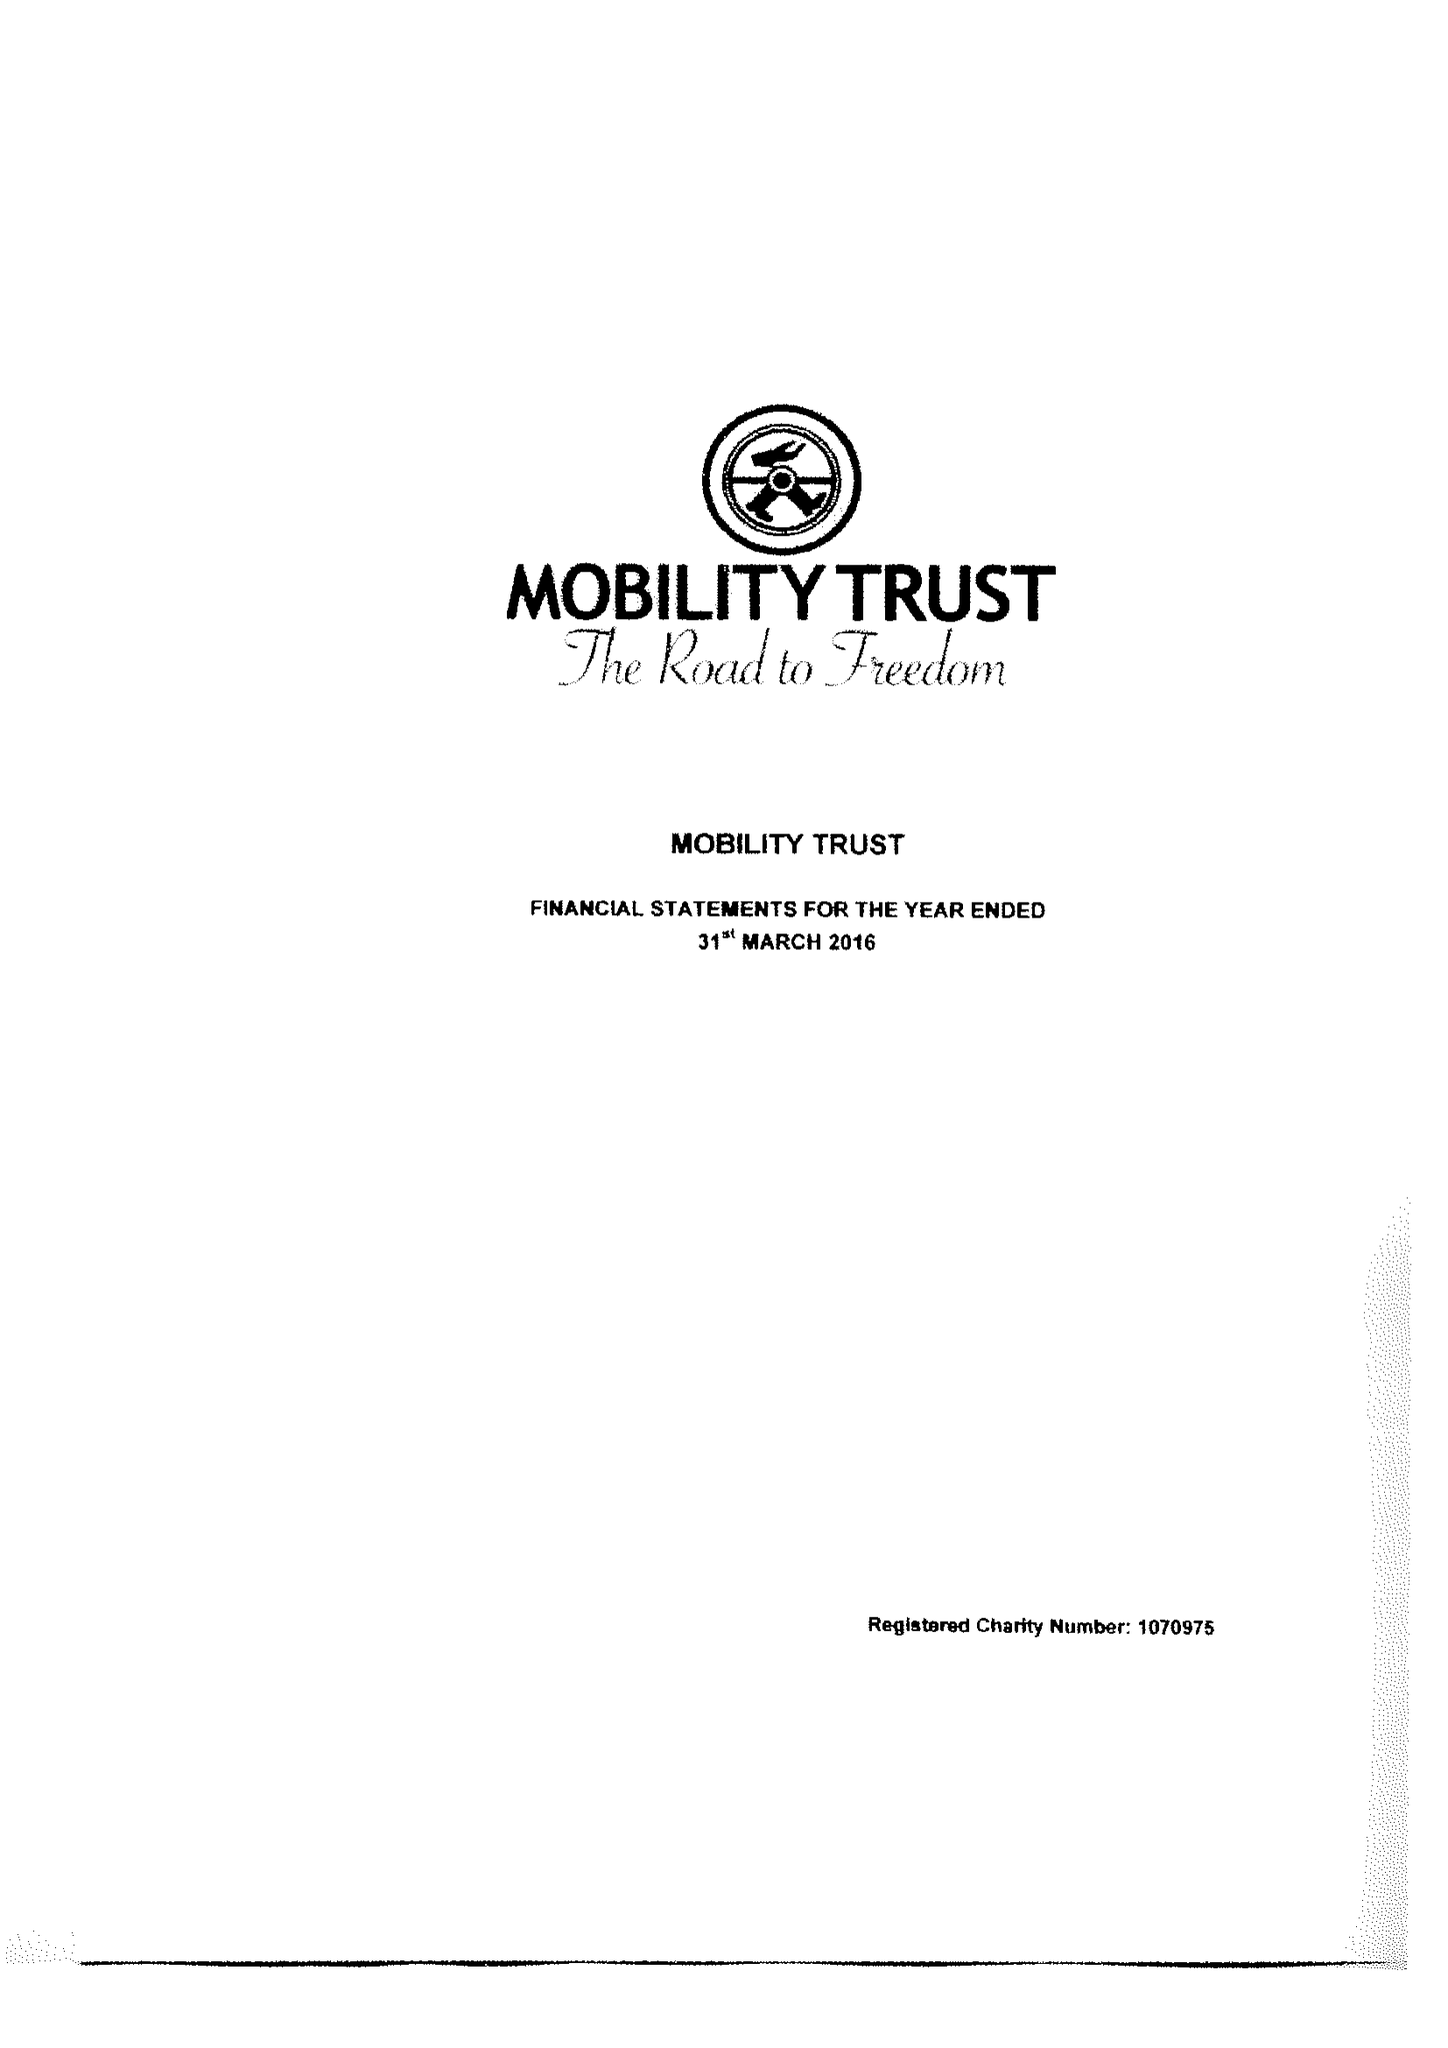What is the value for the address__post_town?
Answer the question using a single word or phrase. READING 